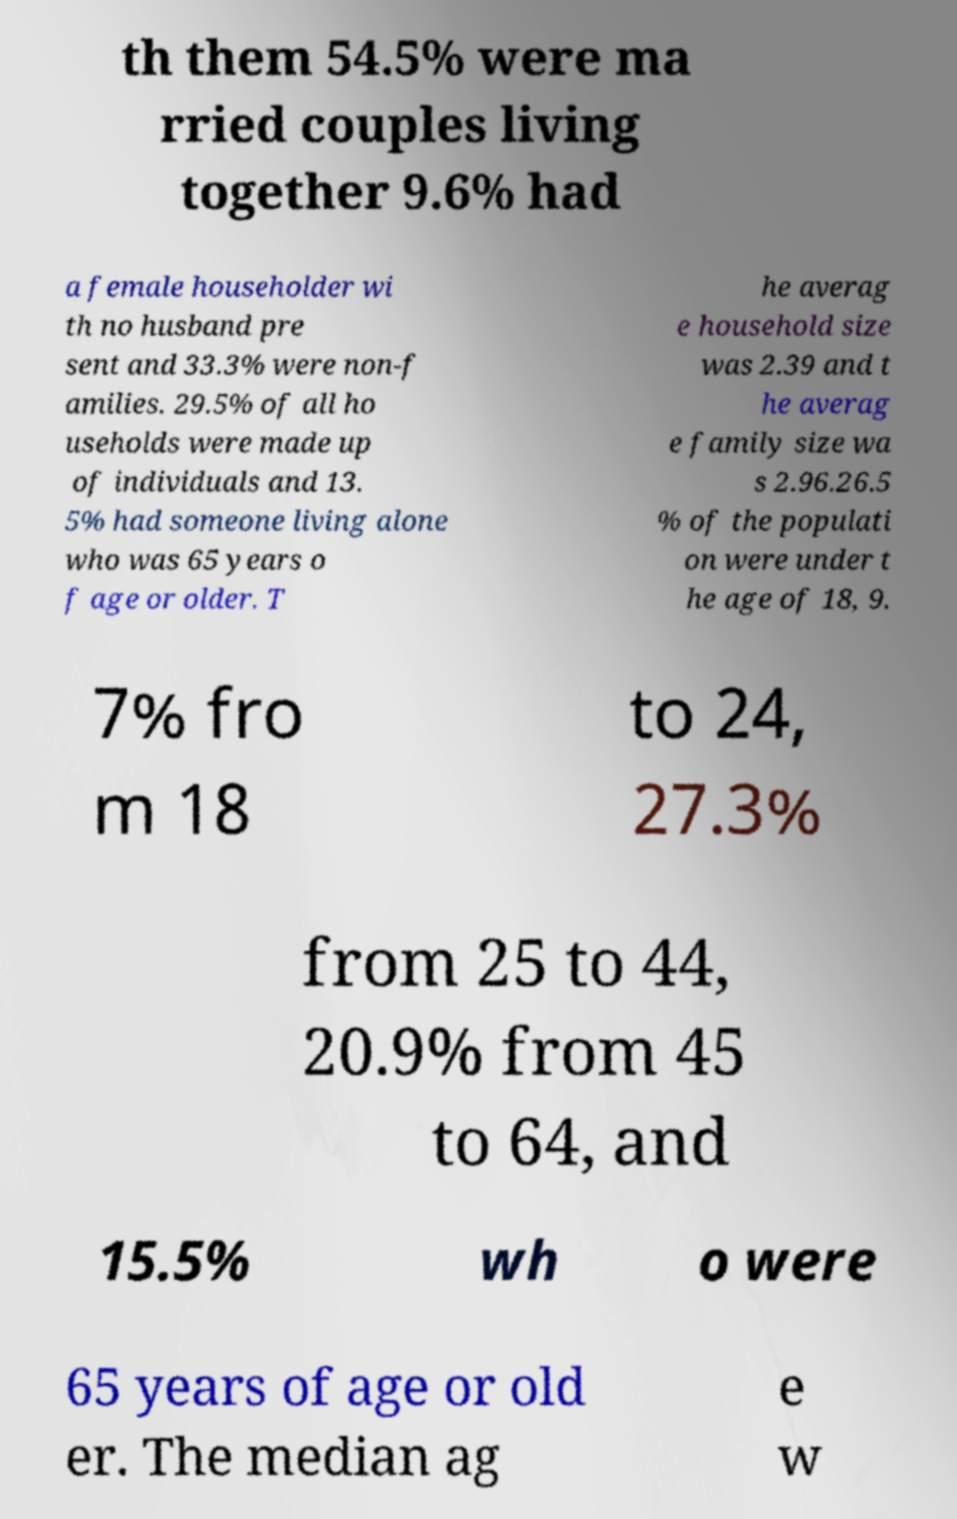What messages or text are displayed in this image? I need them in a readable, typed format. th them 54.5% were ma rried couples living together 9.6% had a female householder wi th no husband pre sent and 33.3% were non-f amilies. 29.5% of all ho useholds were made up of individuals and 13. 5% had someone living alone who was 65 years o f age or older. T he averag e household size was 2.39 and t he averag e family size wa s 2.96.26.5 % of the populati on were under t he age of 18, 9. 7% fro m 18 to 24, 27.3% from 25 to 44, 20.9% from 45 to 64, and 15.5% wh o were 65 years of age or old er. The median ag e w 